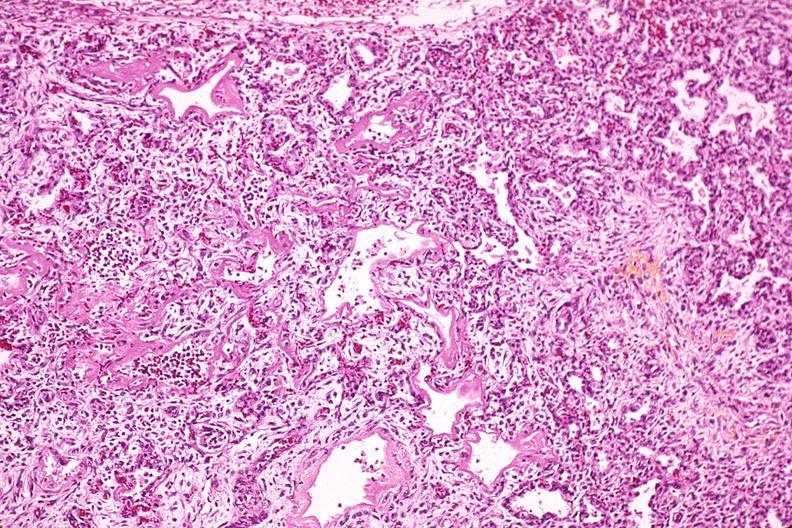what does this image show?
Answer the question using a single word or phrase. Lung 